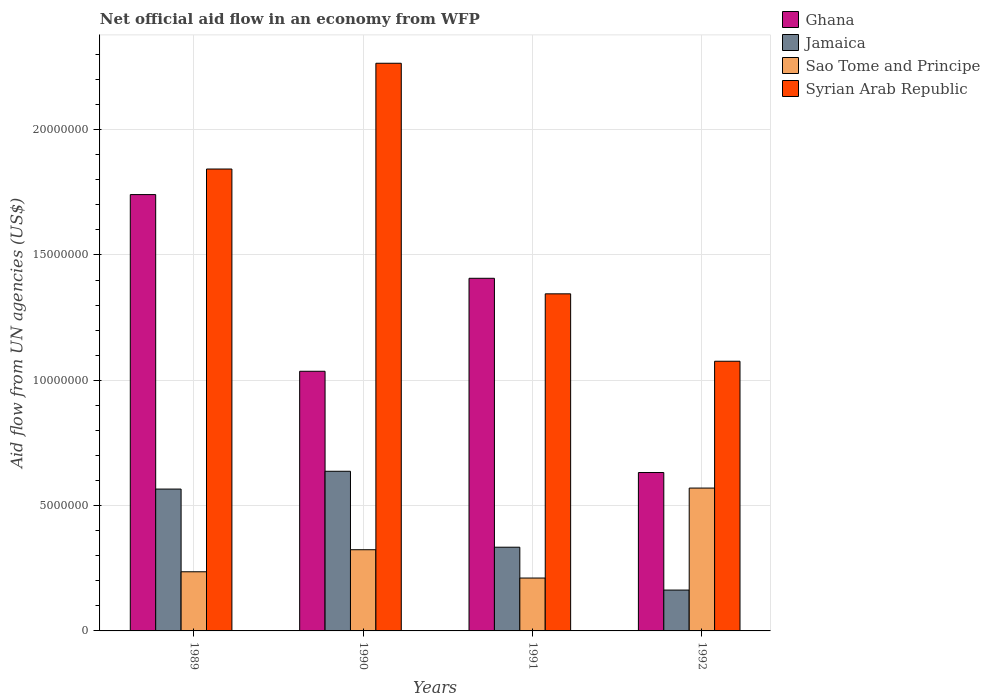How many groups of bars are there?
Your response must be concise. 4. Are the number of bars per tick equal to the number of legend labels?
Keep it short and to the point. Yes. Are the number of bars on each tick of the X-axis equal?
Give a very brief answer. Yes. What is the label of the 2nd group of bars from the left?
Ensure brevity in your answer.  1990. In how many cases, is the number of bars for a given year not equal to the number of legend labels?
Give a very brief answer. 0. What is the net official aid flow in Sao Tome and Principe in 1990?
Your answer should be compact. 3.24e+06. Across all years, what is the maximum net official aid flow in Ghana?
Your response must be concise. 1.74e+07. Across all years, what is the minimum net official aid flow in Jamaica?
Provide a short and direct response. 1.63e+06. In which year was the net official aid flow in Sao Tome and Principe maximum?
Offer a very short reply. 1992. What is the total net official aid flow in Sao Tome and Principe in the graph?
Provide a short and direct response. 1.34e+07. What is the difference between the net official aid flow in Jamaica in 1989 and that in 1990?
Make the answer very short. -7.10e+05. What is the difference between the net official aid flow in Jamaica in 1992 and the net official aid flow in Ghana in 1991?
Ensure brevity in your answer.  -1.24e+07. What is the average net official aid flow in Syrian Arab Republic per year?
Give a very brief answer. 1.63e+07. In the year 1989, what is the difference between the net official aid flow in Sao Tome and Principe and net official aid flow in Ghana?
Your answer should be compact. -1.50e+07. What is the ratio of the net official aid flow in Jamaica in 1989 to that in 1990?
Make the answer very short. 0.89. Is the net official aid flow in Jamaica in 1991 less than that in 1992?
Keep it short and to the point. No. Is the difference between the net official aid flow in Sao Tome and Principe in 1990 and 1991 greater than the difference between the net official aid flow in Ghana in 1990 and 1991?
Your answer should be compact. Yes. What is the difference between the highest and the second highest net official aid flow in Ghana?
Ensure brevity in your answer.  3.34e+06. What is the difference between the highest and the lowest net official aid flow in Jamaica?
Provide a succinct answer. 4.74e+06. In how many years, is the net official aid flow in Syrian Arab Republic greater than the average net official aid flow in Syrian Arab Republic taken over all years?
Offer a terse response. 2. Is the sum of the net official aid flow in Sao Tome and Principe in 1989 and 1991 greater than the maximum net official aid flow in Ghana across all years?
Provide a short and direct response. No. What does the 3rd bar from the left in 1991 represents?
Keep it short and to the point. Sao Tome and Principe. What does the 1st bar from the right in 1991 represents?
Provide a succinct answer. Syrian Arab Republic. How many bars are there?
Provide a short and direct response. 16. What is the difference between two consecutive major ticks on the Y-axis?
Your response must be concise. 5.00e+06. Does the graph contain any zero values?
Give a very brief answer. No. Does the graph contain grids?
Keep it short and to the point. Yes. How many legend labels are there?
Your answer should be very brief. 4. How are the legend labels stacked?
Keep it short and to the point. Vertical. What is the title of the graph?
Offer a very short reply. Net official aid flow in an economy from WFP. Does "Liechtenstein" appear as one of the legend labels in the graph?
Keep it short and to the point. No. What is the label or title of the Y-axis?
Ensure brevity in your answer.  Aid flow from UN agencies (US$). What is the Aid flow from UN agencies (US$) of Ghana in 1989?
Your answer should be compact. 1.74e+07. What is the Aid flow from UN agencies (US$) in Jamaica in 1989?
Ensure brevity in your answer.  5.66e+06. What is the Aid flow from UN agencies (US$) in Sao Tome and Principe in 1989?
Provide a short and direct response. 2.36e+06. What is the Aid flow from UN agencies (US$) of Syrian Arab Republic in 1989?
Ensure brevity in your answer.  1.84e+07. What is the Aid flow from UN agencies (US$) of Ghana in 1990?
Keep it short and to the point. 1.04e+07. What is the Aid flow from UN agencies (US$) in Jamaica in 1990?
Your answer should be compact. 6.37e+06. What is the Aid flow from UN agencies (US$) of Sao Tome and Principe in 1990?
Ensure brevity in your answer.  3.24e+06. What is the Aid flow from UN agencies (US$) in Syrian Arab Republic in 1990?
Offer a terse response. 2.26e+07. What is the Aid flow from UN agencies (US$) in Ghana in 1991?
Provide a succinct answer. 1.41e+07. What is the Aid flow from UN agencies (US$) in Jamaica in 1991?
Give a very brief answer. 3.34e+06. What is the Aid flow from UN agencies (US$) of Sao Tome and Principe in 1991?
Your answer should be very brief. 2.11e+06. What is the Aid flow from UN agencies (US$) in Syrian Arab Republic in 1991?
Offer a terse response. 1.34e+07. What is the Aid flow from UN agencies (US$) of Ghana in 1992?
Make the answer very short. 6.32e+06. What is the Aid flow from UN agencies (US$) of Jamaica in 1992?
Your response must be concise. 1.63e+06. What is the Aid flow from UN agencies (US$) in Sao Tome and Principe in 1992?
Offer a very short reply. 5.70e+06. What is the Aid flow from UN agencies (US$) of Syrian Arab Republic in 1992?
Offer a very short reply. 1.08e+07. Across all years, what is the maximum Aid flow from UN agencies (US$) of Ghana?
Your answer should be very brief. 1.74e+07. Across all years, what is the maximum Aid flow from UN agencies (US$) of Jamaica?
Your response must be concise. 6.37e+06. Across all years, what is the maximum Aid flow from UN agencies (US$) in Sao Tome and Principe?
Ensure brevity in your answer.  5.70e+06. Across all years, what is the maximum Aid flow from UN agencies (US$) in Syrian Arab Republic?
Provide a succinct answer. 2.26e+07. Across all years, what is the minimum Aid flow from UN agencies (US$) in Ghana?
Offer a terse response. 6.32e+06. Across all years, what is the minimum Aid flow from UN agencies (US$) of Jamaica?
Provide a succinct answer. 1.63e+06. Across all years, what is the minimum Aid flow from UN agencies (US$) of Sao Tome and Principe?
Ensure brevity in your answer.  2.11e+06. Across all years, what is the minimum Aid flow from UN agencies (US$) in Syrian Arab Republic?
Keep it short and to the point. 1.08e+07. What is the total Aid flow from UN agencies (US$) of Ghana in the graph?
Make the answer very short. 4.82e+07. What is the total Aid flow from UN agencies (US$) of Jamaica in the graph?
Ensure brevity in your answer.  1.70e+07. What is the total Aid flow from UN agencies (US$) of Sao Tome and Principe in the graph?
Your response must be concise. 1.34e+07. What is the total Aid flow from UN agencies (US$) of Syrian Arab Republic in the graph?
Offer a terse response. 6.53e+07. What is the difference between the Aid flow from UN agencies (US$) in Ghana in 1989 and that in 1990?
Your answer should be very brief. 7.05e+06. What is the difference between the Aid flow from UN agencies (US$) in Jamaica in 1989 and that in 1990?
Make the answer very short. -7.10e+05. What is the difference between the Aid flow from UN agencies (US$) of Sao Tome and Principe in 1989 and that in 1990?
Ensure brevity in your answer.  -8.80e+05. What is the difference between the Aid flow from UN agencies (US$) of Syrian Arab Republic in 1989 and that in 1990?
Offer a terse response. -4.22e+06. What is the difference between the Aid flow from UN agencies (US$) of Ghana in 1989 and that in 1991?
Make the answer very short. 3.34e+06. What is the difference between the Aid flow from UN agencies (US$) in Jamaica in 1989 and that in 1991?
Your answer should be compact. 2.32e+06. What is the difference between the Aid flow from UN agencies (US$) in Syrian Arab Republic in 1989 and that in 1991?
Offer a very short reply. 4.98e+06. What is the difference between the Aid flow from UN agencies (US$) in Ghana in 1989 and that in 1992?
Offer a very short reply. 1.11e+07. What is the difference between the Aid flow from UN agencies (US$) in Jamaica in 1989 and that in 1992?
Provide a succinct answer. 4.03e+06. What is the difference between the Aid flow from UN agencies (US$) of Sao Tome and Principe in 1989 and that in 1992?
Provide a short and direct response. -3.34e+06. What is the difference between the Aid flow from UN agencies (US$) of Syrian Arab Republic in 1989 and that in 1992?
Make the answer very short. 7.67e+06. What is the difference between the Aid flow from UN agencies (US$) in Ghana in 1990 and that in 1991?
Provide a succinct answer. -3.71e+06. What is the difference between the Aid flow from UN agencies (US$) of Jamaica in 1990 and that in 1991?
Make the answer very short. 3.03e+06. What is the difference between the Aid flow from UN agencies (US$) in Sao Tome and Principe in 1990 and that in 1991?
Keep it short and to the point. 1.13e+06. What is the difference between the Aid flow from UN agencies (US$) in Syrian Arab Republic in 1990 and that in 1991?
Make the answer very short. 9.20e+06. What is the difference between the Aid flow from UN agencies (US$) in Ghana in 1990 and that in 1992?
Ensure brevity in your answer.  4.04e+06. What is the difference between the Aid flow from UN agencies (US$) of Jamaica in 1990 and that in 1992?
Your answer should be compact. 4.74e+06. What is the difference between the Aid flow from UN agencies (US$) of Sao Tome and Principe in 1990 and that in 1992?
Ensure brevity in your answer.  -2.46e+06. What is the difference between the Aid flow from UN agencies (US$) in Syrian Arab Republic in 1990 and that in 1992?
Make the answer very short. 1.19e+07. What is the difference between the Aid flow from UN agencies (US$) of Ghana in 1991 and that in 1992?
Give a very brief answer. 7.75e+06. What is the difference between the Aid flow from UN agencies (US$) of Jamaica in 1991 and that in 1992?
Ensure brevity in your answer.  1.71e+06. What is the difference between the Aid flow from UN agencies (US$) of Sao Tome and Principe in 1991 and that in 1992?
Your answer should be very brief. -3.59e+06. What is the difference between the Aid flow from UN agencies (US$) of Syrian Arab Republic in 1991 and that in 1992?
Ensure brevity in your answer.  2.69e+06. What is the difference between the Aid flow from UN agencies (US$) in Ghana in 1989 and the Aid flow from UN agencies (US$) in Jamaica in 1990?
Offer a terse response. 1.10e+07. What is the difference between the Aid flow from UN agencies (US$) in Ghana in 1989 and the Aid flow from UN agencies (US$) in Sao Tome and Principe in 1990?
Offer a terse response. 1.42e+07. What is the difference between the Aid flow from UN agencies (US$) in Ghana in 1989 and the Aid flow from UN agencies (US$) in Syrian Arab Republic in 1990?
Give a very brief answer. -5.24e+06. What is the difference between the Aid flow from UN agencies (US$) of Jamaica in 1989 and the Aid flow from UN agencies (US$) of Sao Tome and Principe in 1990?
Give a very brief answer. 2.42e+06. What is the difference between the Aid flow from UN agencies (US$) of Jamaica in 1989 and the Aid flow from UN agencies (US$) of Syrian Arab Republic in 1990?
Your answer should be very brief. -1.70e+07. What is the difference between the Aid flow from UN agencies (US$) in Sao Tome and Principe in 1989 and the Aid flow from UN agencies (US$) in Syrian Arab Republic in 1990?
Your answer should be compact. -2.03e+07. What is the difference between the Aid flow from UN agencies (US$) of Ghana in 1989 and the Aid flow from UN agencies (US$) of Jamaica in 1991?
Make the answer very short. 1.41e+07. What is the difference between the Aid flow from UN agencies (US$) in Ghana in 1989 and the Aid flow from UN agencies (US$) in Sao Tome and Principe in 1991?
Offer a terse response. 1.53e+07. What is the difference between the Aid flow from UN agencies (US$) of Ghana in 1989 and the Aid flow from UN agencies (US$) of Syrian Arab Republic in 1991?
Make the answer very short. 3.96e+06. What is the difference between the Aid flow from UN agencies (US$) of Jamaica in 1989 and the Aid flow from UN agencies (US$) of Sao Tome and Principe in 1991?
Your answer should be very brief. 3.55e+06. What is the difference between the Aid flow from UN agencies (US$) in Jamaica in 1989 and the Aid flow from UN agencies (US$) in Syrian Arab Republic in 1991?
Your response must be concise. -7.79e+06. What is the difference between the Aid flow from UN agencies (US$) of Sao Tome and Principe in 1989 and the Aid flow from UN agencies (US$) of Syrian Arab Republic in 1991?
Offer a terse response. -1.11e+07. What is the difference between the Aid flow from UN agencies (US$) of Ghana in 1989 and the Aid flow from UN agencies (US$) of Jamaica in 1992?
Your answer should be very brief. 1.58e+07. What is the difference between the Aid flow from UN agencies (US$) of Ghana in 1989 and the Aid flow from UN agencies (US$) of Sao Tome and Principe in 1992?
Provide a short and direct response. 1.17e+07. What is the difference between the Aid flow from UN agencies (US$) in Ghana in 1989 and the Aid flow from UN agencies (US$) in Syrian Arab Republic in 1992?
Your response must be concise. 6.65e+06. What is the difference between the Aid flow from UN agencies (US$) of Jamaica in 1989 and the Aid flow from UN agencies (US$) of Syrian Arab Republic in 1992?
Provide a short and direct response. -5.10e+06. What is the difference between the Aid flow from UN agencies (US$) in Sao Tome and Principe in 1989 and the Aid flow from UN agencies (US$) in Syrian Arab Republic in 1992?
Provide a short and direct response. -8.40e+06. What is the difference between the Aid flow from UN agencies (US$) of Ghana in 1990 and the Aid flow from UN agencies (US$) of Jamaica in 1991?
Your answer should be compact. 7.02e+06. What is the difference between the Aid flow from UN agencies (US$) in Ghana in 1990 and the Aid flow from UN agencies (US$) in Sao Tome and Principe in 1991?
Your answer should be compact. 8.25e+06. What is the difference between the Aid flow from UN agencies (US$) in Ghana in 1990 and the Aid flow from UN agencies (US$) in Syrian Arab Republic in 1991?
Provide a succinct answer. -3.09e+06. What is the difference between the Aid flow from UN agencies (US$) of Jamaica in 1990 and the Aid flow from UN agencies (US$) of Sao Tome and Principe in 1991?
Provide a short and direct response. 4.26e+06. What is the difference between the Aid flow from UN agencies (US$) of Jamaica in 1990 and the Aid flow from UN agencies (US$) of Syrian Arab Republic in 1991?
Ensure brevity in your answer.  -7.08e+06. What is the difference between the Aid flow from UN agencies (US$) in Sao Tome and Principe in 1990 and the Aid flow from UN agencies (US$) in Syrian Arab Republic in 1991?
Offer a terse response. -1.02e+07. What is the difference between the Aid flow from UN agencies (US$) of Ghana in 1990 and the Aid flow from UN agencies (US$) of Jamaica in 1992?
Offer a very short reply. 8.73e+06. What is the difference between the Aid flow from UN agencies (US$) in Ghana in 1990 and the Aid flow from UN agencies (US$) in Sao Tome and Principe in 1992?
Your answer should be very brief. 4.66e+06. What is the difference between the Aid flow from UN agencies (US$) of Ghana in 1990 and the Aid flow from UN agencies (US$) of Syrian Arab Republic in 1992?
Keep it short and to the point. -4.00e+05. What is the difference between the Aid flow from UN agencies (US$) in Jamaica in 1990 and the Aid flow from UN agencies (US$) in Sao Tome and Principe in 1992?
Your answer should be very brief. 6.70e+05. What is the difference between the Aid flow from UN agencies (US$) of Jamaica in 1990 and the Aid flow from UN agencies (US$) of Syrian Arab Republic in 1992?
Your response must be concise. -4.39e+06. What is the difference between the Aid flow from UN agencies (US$) of Sao Tome and Principe in 1990 and the Aid flow from UN agencies (US$) of Syrian Arab Republic in 1992?
Keep it short and to the point. -7.52e+06. What is the difference between the Aid flow from UN agencies (US$) in Ghana in 1991 and the Aid flow from UN agencies (US$) in Jamaica in 1992?
Your response must be concise. 1.24e+07. What is the difference between the Aid flow from UN agencies (US$) in Ghana in 1991 and the Aid flow from UN agencies (US$) in Sao Tome and Principe in 1992?
Make the answer very short. 8.37e+06. What is the difference between the Aid flow from UN agencies (US$) of Ghana in 1991 and the Aid flow from UN agencies (US$) of Syrian Arab Republic in 1992?
Keep it short and to the point. 3.31e+06. What is the difference between the Aid flow from UN agencies (US$) of Jamaica in 1991 and the Aid flow from UN agencies (US$) of Sao Tome and Principe in 1992?
Offer a terse response. -2.36e+06. What is the difference between the Aid flow from UN agencies (US$) of Jamaica in 1991 and the Aid flow from UN agencies (US$) of Syrian Arab Republic in 1992?
Your answer should be very brief. -7.42e+06. What is the difference between the Aid flow from UN agencies (US$) in Sao Tome and Principe in 1991 and the Aid flow from UN agencies (US$) in Syrian Arab Republic in 1992?
Provide a succinct answer. -8.65e+06. What is the average Aid flow from UN agencies (US$) of Ghana per year?
Offer a terse response. 1.20e+07. What is the average Aid flow from UN agencies (US$) of Jamaica per year?
Offer a very short reply. 4.25e+06. What is the average Aid flow from UN agencies (US$) in Sao Tome and Principe per year?
Ensure brevity in your answer.  3.35e+06. What is the average Aid flow from UN agencies (US$) of Syrian Arab Republic per year?
Make the answer very short. 1.63e+07. In the year 1989, what is the difference between the Aid flow from UN agencies (US$) in Ghana and Aid flow from UN agencies (US$) in Jamaica?
Keep it short and to the point. 1.18e+07. In the year 1989, what is the difference between the Aid flow from UN agencies (US$) of Ghana and Aid flow from UN agencies (US$) of Sao Tome and Principe?
Give a very brief answer. 1.50e+07. In the year 1989, what is the difference between the Aid flow from UN agencies (US$) of Ghana and Aid flow from UN agencies (US$) of Syrian Arab Republic?
Provide a short and direct response. -1.02e+06. In the year 1989, what is the difference between the Aid flow from UN agencies (US$) of Jamaica and Aid flow from UN agencies (US$) of Sao Tome and Principe?
Your response must be concise. 3.30e+06. In the year 1989, what is the difference between the Aid flow from UN agencies (US$) in Jamaica and Aid flow from UN agencies (US$) in Syrian Arab Republic?
Offer a terse response. -1.28e+07. In the year 1989, what is the difference between the Aid flow from UN agencies (US$) of Sao Tome and Principe and Aid flow from UN agencies (US$) of Syrian Arab Republic?
Offer a very short reply. -1.61e+07. In the year 1990, what is the difference between the Aid flow from UN agencies (US$) of Ghana and Aid flow from UN agencies (US$) of Jamaica?
Your answer should be compact. 3.99e+06. In the year 1990, what is the difference between the Aid flow from UN agencies (US$) of Ghana and Aid flow from UN agencies (US$) of Sao Tome and Principe?
Offer a very short reply. 7.12e+06. In the year 1990, what is the difference between the Aid flow from UN agencies (US$) of Ghana and Aid flow from UN agencies (US$) of Syrian Arab Republic?
Ensure brevity in your answer.  -1.23e+07. In the year 1990, what is the difference between the Aid flow from UN agencies (US$) in Jamaica and Aid flow from UN agencies (US$) in Sao Tome and Principe?
Keep it short and to the point. 3.13e+06. In the year 1990, what is the difference between the Aid flow from UN agencies (US$) in Jamaica and Aid flow from UN agencies (US$) in Syrian Arab Republic?
Provide a short and direct response. -1.63e+07. In the year 1990, what is the difference between the Aid flow from UN agencies (US$) in Sao Tome and Principe and Aid flow from UN agencies (US$) in Syrian Arab Republic?
Your answer should be very brief. -1.94e+07. In the year 1991, what is the difference between the Aid flow from UN agencies (US$) of Ghana and Aid flow from UN agencies (US$) of Jamaica?
Your response must be concise. 1.07e+07. In the year 1991, what is the difference between the Aid flow from UN agencies (US$) of Ghana and Aid flow from UN agencies (US$) of Sao Tome and Principe?
Keep it short and to the point. 1.20e+07. In the year 1991, what is the difference between the Aid flow from UN agencies (US$) in Ghana and Aid flow from UN agencies (US$) in Syrian Arab Republic?
Your answer should be very brief. 6.20e+05. In the year 1991, what is the difference between the Aid flow from UN agencies (US$) in Jamaica and Aid flow from UN agencies (US$) in Sao Tome and Principe?
Provide a short and direct response. 1.23e+06. In the year 1991, what is the difference between the Aid flow from UN agencies (US$) in Jamaica and Aid flow from UN agencies (US$) in Syrian Arab Republic?
Provide a short and direct response. -1.01e+07. In the year 1991, what is the difference between the Aid flow from UN agencies (US$) in Sao Tome and Principe and Aid flow from UN agencies (US$) in Syrian Arab Republic?
Offer a terse response. -1.13e+07. In the year 1992, what is the difference between the Aid flow from UN agencies (US$) of Ghana and Aid flow from UN agencies (US$) of Jamaica?
Your answer should be very brief. 4.69e+06. In the year 1992, what is the difference between the Aid flow from UN agencies (US$) in Ghana and Aid flow from UN agencies (US$) in Sao Tome and Principe?
Offer a terse response. 6.20e+05. In the year 1992, what is the difference between the Aid flow from UN agencies (US$) of Ghana and Aid flow from UN agencies (US$) of Syrian Arab Republic?
Make the answer very short. -4.44e+06. In the year 1992, what is the difference between the Aid flow from UN agencies (US$) of Jamaica and Aid flow from UN agencies (US$) of Sao Tome and Principe?
Offer a terse response. -4.07e+06. In the year 1992, what is the difference between the Aid flow from UN agencies (US$) of Jamaica and Aid flow from UN agencies (US$) of Syrian Arab Republic?
Your answer should be very brief. -9.13e+06. In the year 1992, what is the difference between the Aid flow from UN agencies (US$) of Sao Tome and Principe and Aid flow from UN agencies (US$) of Syrian Arab Republic?
Your answer should be compact. -5.06e+06. What is the ratio of the Aid flow from UN agencies (US$) of Ghana in 1989 to that in 1990?
Offer a very short reply. 1.68. What is the ratio of the Aid flow from UN agencies (US$) of Jamaica in 1989 to that in 1990?
Provide a short and direct response. 0.89. What is the ratio of the Aid flow from UN agencies (US$) in Sao Tome and Principe in 1989 to that in 1990?
Keep it short and to the point. 0.73. What is the ratio of the Aid flow from UN agencies (US$) in Syrian Arab Republic in 1989 to that in 1990?
Provide a short and direct response. 0.81. What is the ratio of the Aid flow from UN agencies (US$) of Ghana in 1989 to that in 1991?
Offer a terse response. 1.24. What is the ratio of the Aid flow from UN agencies (US$) of Jamaica in 1989 to that in 1991?
Make the answer very short. 1.69. What is the ratio of the Aid flow from UN agencies (US$) of Sao Tome and Principe in 1989 to that in 1991?
Your answer should be very brief. 1.12. What is the ratio of the Aid flow from UN agencies (US$) in Syrian Arab Republic in 1989 to that in 1991?
Offer a terse response. 1.37. What is the ratio of the Aid flow from UN agencies (US$) of Ghana in 1989 to that in 1992?
Offer a terse response. 2.75. What is the ratio of the Aid flow from UN agencies (US$) of Jamaica in 1989 to that in 1992?
Your answer should be very brief. 3.47. What is the ratio of the Aid flow from UN agencies (US$) in Sao Tome and Principe in 1989 to that in 1992?
Offer a terse response. 0.41. What is the ratio of the Aid flow from UN agencies (US$) of Syrian Arab Republic in 1989 to that in 1992?
Offer a terse response. 1.71. What is the ratio of the Aid flow from UN agencies (US$) in Ghana in 1990 to that in 1991?
Your answer should be compact. 0.74. What is the ratio of the Aid flow from UN agencies (US$) in Jamaica in 1990 to that in 1991?
Give a very brief answer. 1.91. What is the ratio of the Aid flow from UN agencies (US$) in Sao Tome and Principe in 1990 to that in 1991?
Your answer should be compact. 1.54. What is the ratio of the Aid flow from UN agencies (US$) in Syrian Arab Republic in 1990 to that in 1991?
Offer a very short reply. 1.68. What is the ratio of the Aid flow from UN agencies (US$) of Ghana in 1990 to that in 1992?
Offer a terse response. 1.64. What is the ratio of the Aid flow from UN agencies (US$) in Jamaica in 1990 to that in 1992?
Provide a succinct answer. 3.91. What is the ratio of the Aid flow from UN agencies (US$) of Sao Tome and Principe in 1990 to that in 1992?
Offer a very short reply. 0.57. What is the ratio of the Aid flow from UN agencies (US$) in Syrian Arab Republic in 1990 to that in 1992?
Make the answer very short. 2.1. What is the ratio of the Aid flow from UN agencies (US$) in Ghana in 1991 to that in 1992?
Keep it short and to the point. 2.23. What is the ratio of the Aid flow from UN agencies (US$) of Jamaica in 1991 to that in 1992?
Give a very brief answer. 2.05. What is the ratio of the Aid flow from UN agencies (US$) of Sao Tome and Principe in 1991 to that in 1992?
Offer a terse response. 0.37. What is the ratio of the Aid flow from UN agencies (US$) of Syrian Arab Republic in 1991 to that in 1992?
Offer a very short reply. 1.25. What is the difference between the highest and the second highest Aid flow from UN agencies (US$) in Ghana?
Ensure brevity in your answer.  3.34e+06. What is the difference between the highest and the second highest Aid flow from UN agencies (US$) in Jamaica?
Ensure brevity in your answer.  7.10e+05. What is the difference between the highest and the second highest Aid flow from UN agencies (US$) in Sao Tome and Principe?
Give a very brief answer. 2.46e+06. What is the difference between the highest and the second highest Aid flow from UN agencies (US$) in Syrian Arab Republic?
Provide a succinct answer. 4.22e+06. What is the difference between the highest and the lowest Aid flow from UN agencies (US$) of Ghana?
Keep it short and to the point. 1.11e+07. What is the difference between the highest and the lowest Aid flow from UN agencies (US$) of Jamaica?
Give a very brief answer. 4.74e+06. What is the difference between the highest and the lowest Aid flow from UN agencies (US$) in Sao Tome and Principe?
Your response must be concise. 3.59e+06. What is the difference between the highest and the lowest Aid flow from UN agencies (US$) in Syrian Arab Republic?
Make the answer very short. 1.19e+07. 